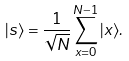<formula> <loc_0><loc_0><loc_500><loc_500>| s \rangle = { \frac { 1 } { \sqrt { N } } } \sum _ { x = 0 } ^ { N - 1 } | x \rangle .</formula> 